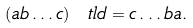Convert formula to latex. <formula><loc_0><loc_0><loc_500><loc_500>( a b \dots c ) \ t l d = c \dots b a .</formula> 